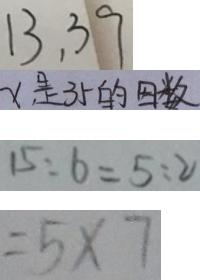<formula> <loc_0><loc_0><loc_500><loc_500>1 3 , 3 9 
 x 是 3 5 的 因 数 
 1 5 : 6 = 5 : 2 
 = 5 \times 7</formula> 